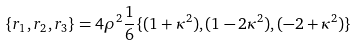<formula> <loc_0><loc_0><loc_500><loc_500>\{ r _ { 1 } , r _ { 2 } , r _ { 3 } \} = 4 \rho ^ { 2 } \frac { 1 } { 6 } \{ ( 1 + \kappa ^ { 2 } ) , ( 1 - 2 \kappa ^ { 2 } ) , ( - 2 + \kappa ^ { 2 } ) \}</formula> 